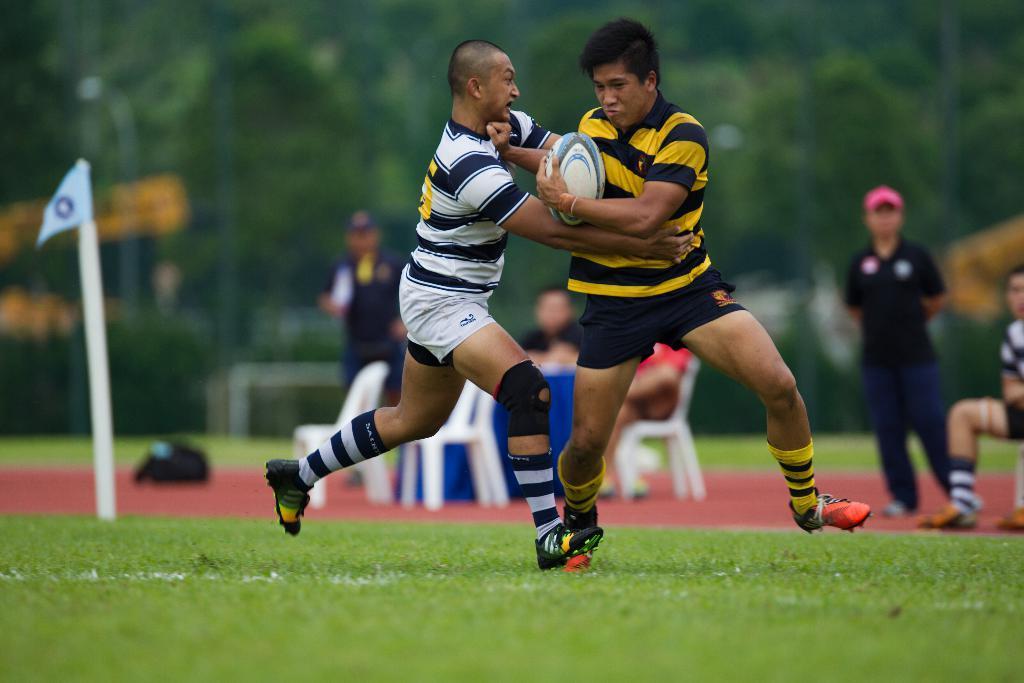Can you describe this image briefly? In this image, we can see persons wearing clothes. There is a person person in the middle of the image holding a ball with his hand. There is a flag on the left side of the image. There are some chairs in the middle of the image. There is a grass on the ground. In the background, image is blurred. 